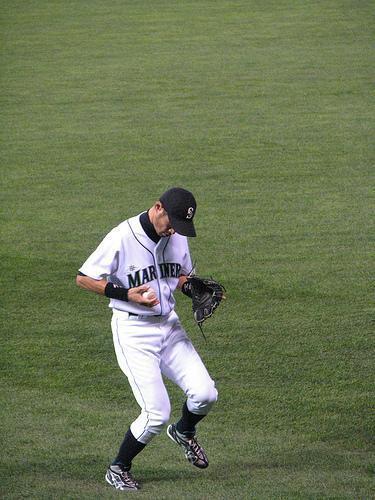How many people do you see?
Give a very brief answer. 1. 